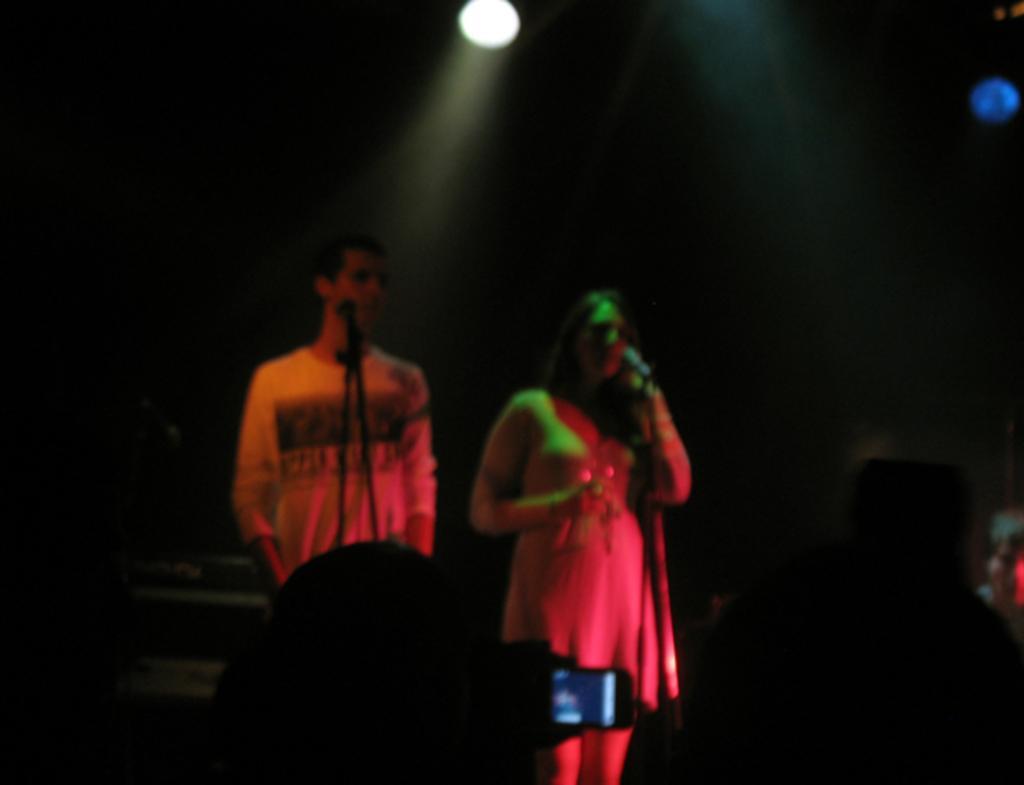Can you describe this image briefly? Here we can see focusing light. In-front of these people there are mics. 